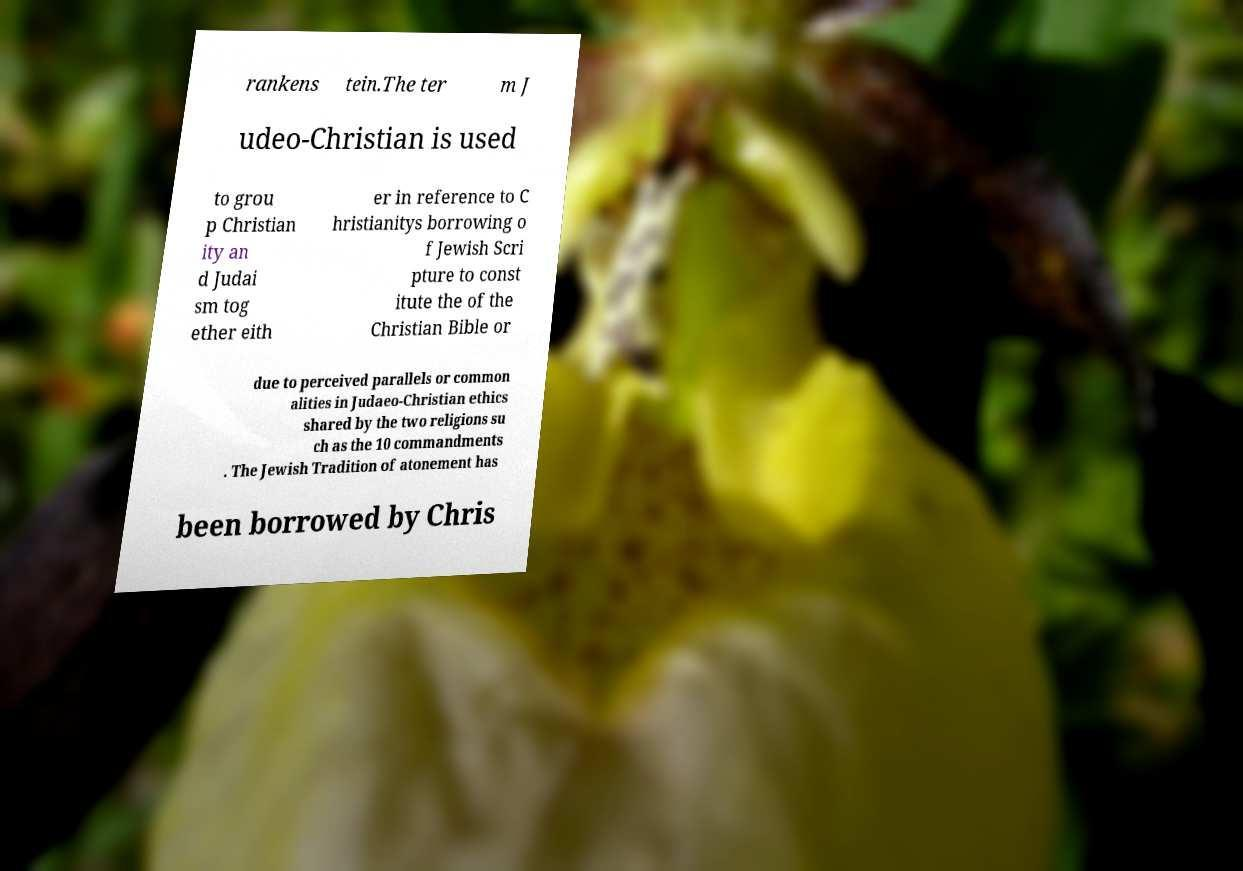There's text embedded in this image that I need extracted. Can you transcribe it verbatim? rankens tein.The ter m J udeo-Christian is used to grou p Christian ity an d Judai sm tog ether eith er in reference to C hristianitys borrowing o f Jewish Scri pture to const itute the of the Christian Bible or due to perceived parallels or common alities in Judaeo-Christian ethics shared by the two religions su ch as the 10 commandments . The Jewish Tradition of atonement has been borrowed by Chris 